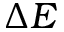<formula> <loc_0><loc_0><loc_500><loc_500>\Delta E</formula> 